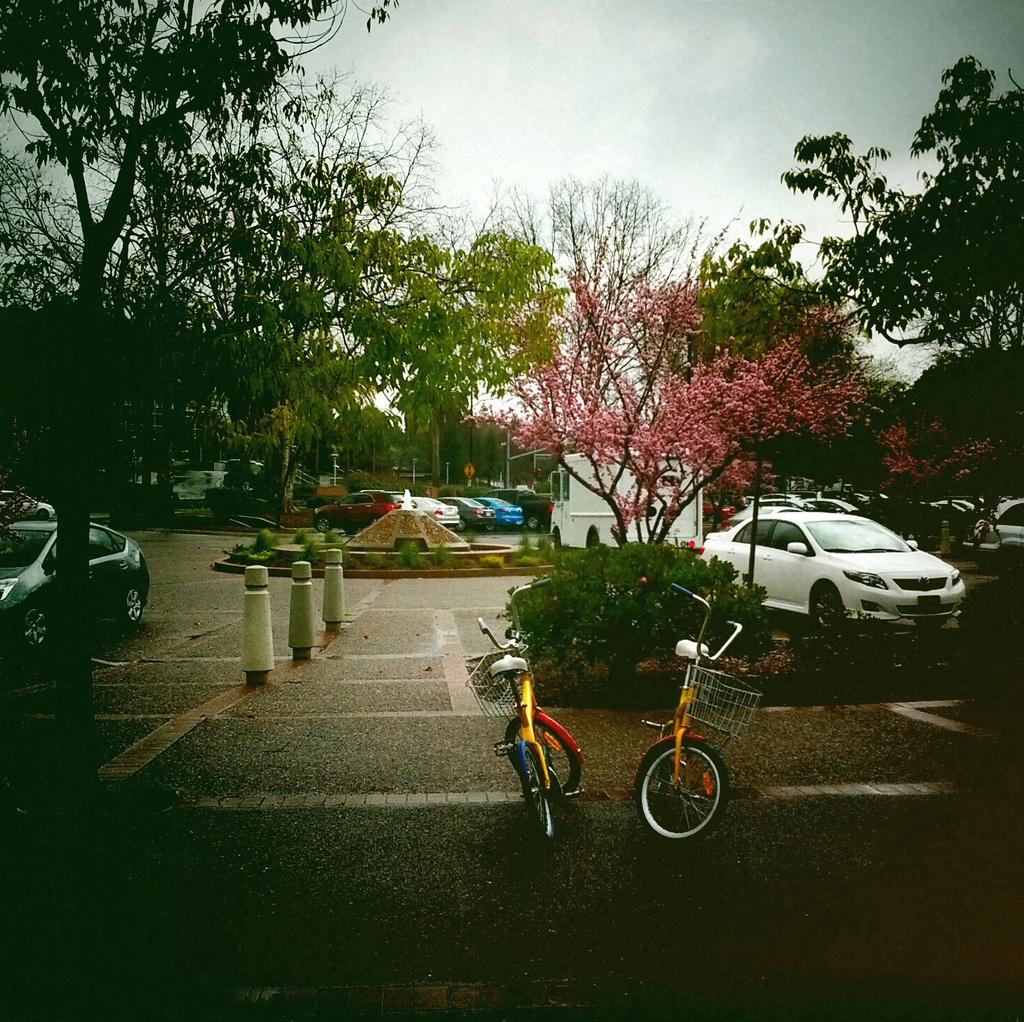What types of transportation can be seen in the image? There are vehicles in the image. What natural elements are present in the image? There are trees and plants in the image. What water feature can be seen in the image? There is a small fountain in the image. What type of bicycles are in the image? There are bicycles in the image. What architectural elements can be seen in the image? There are poles and stone pillars in the image. What part of the natural environment is visible in the image? The sky is visible in the image. What type of wire can be seen connecting the cloud to the hammer in the image? There is no wire, cloud, or hammer present in the image. 